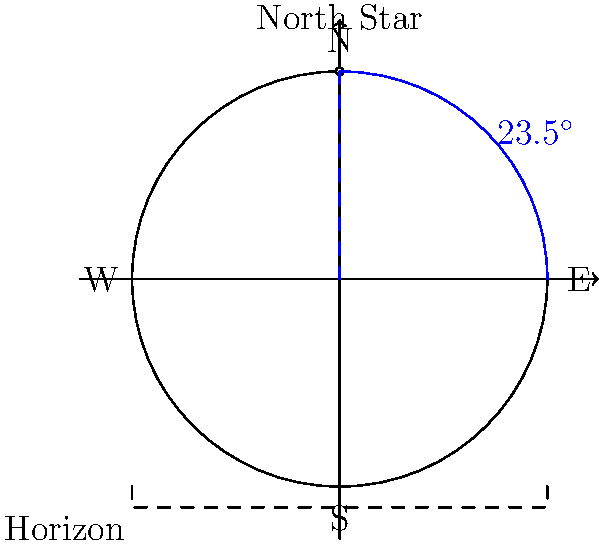As an experienced fisherman, you know the North Star is crucial for navigation. If you observe the North Star at an angle of 23.5° above the horizon, what can you determine about your approximate latitude? To determine the latitude based on the North Star's position, follow these steps:

1. Recall that the angle of the North Star above the horizon is approximately equal to the observer's latitude.

2. In this case, the North Star is observed at an angle of 23.5° above the horizon.

3. This means that the observer's latitude is also approximately 23.5°.

4. The Tropic of Cancer, which marks the northernmost latitude where the Sun can appear directly overhead, is located at approximately 23.5° North latitude.

5. Therefore, observing the North Star at this angle indicates that you are near the Tropic of Cancer.

6. This latitude corresponds to regions such as Hawaii, parts of Mexico, the Bahamas, and northern Africa.

7. For maritime navigation, this information helps determine your north-south position on the globe, which is crucial for plotting courses and understanding ocean currents and weather patterns.
Answer: Approximately 23.5° North latitude (near the Tropic of Cancer) 